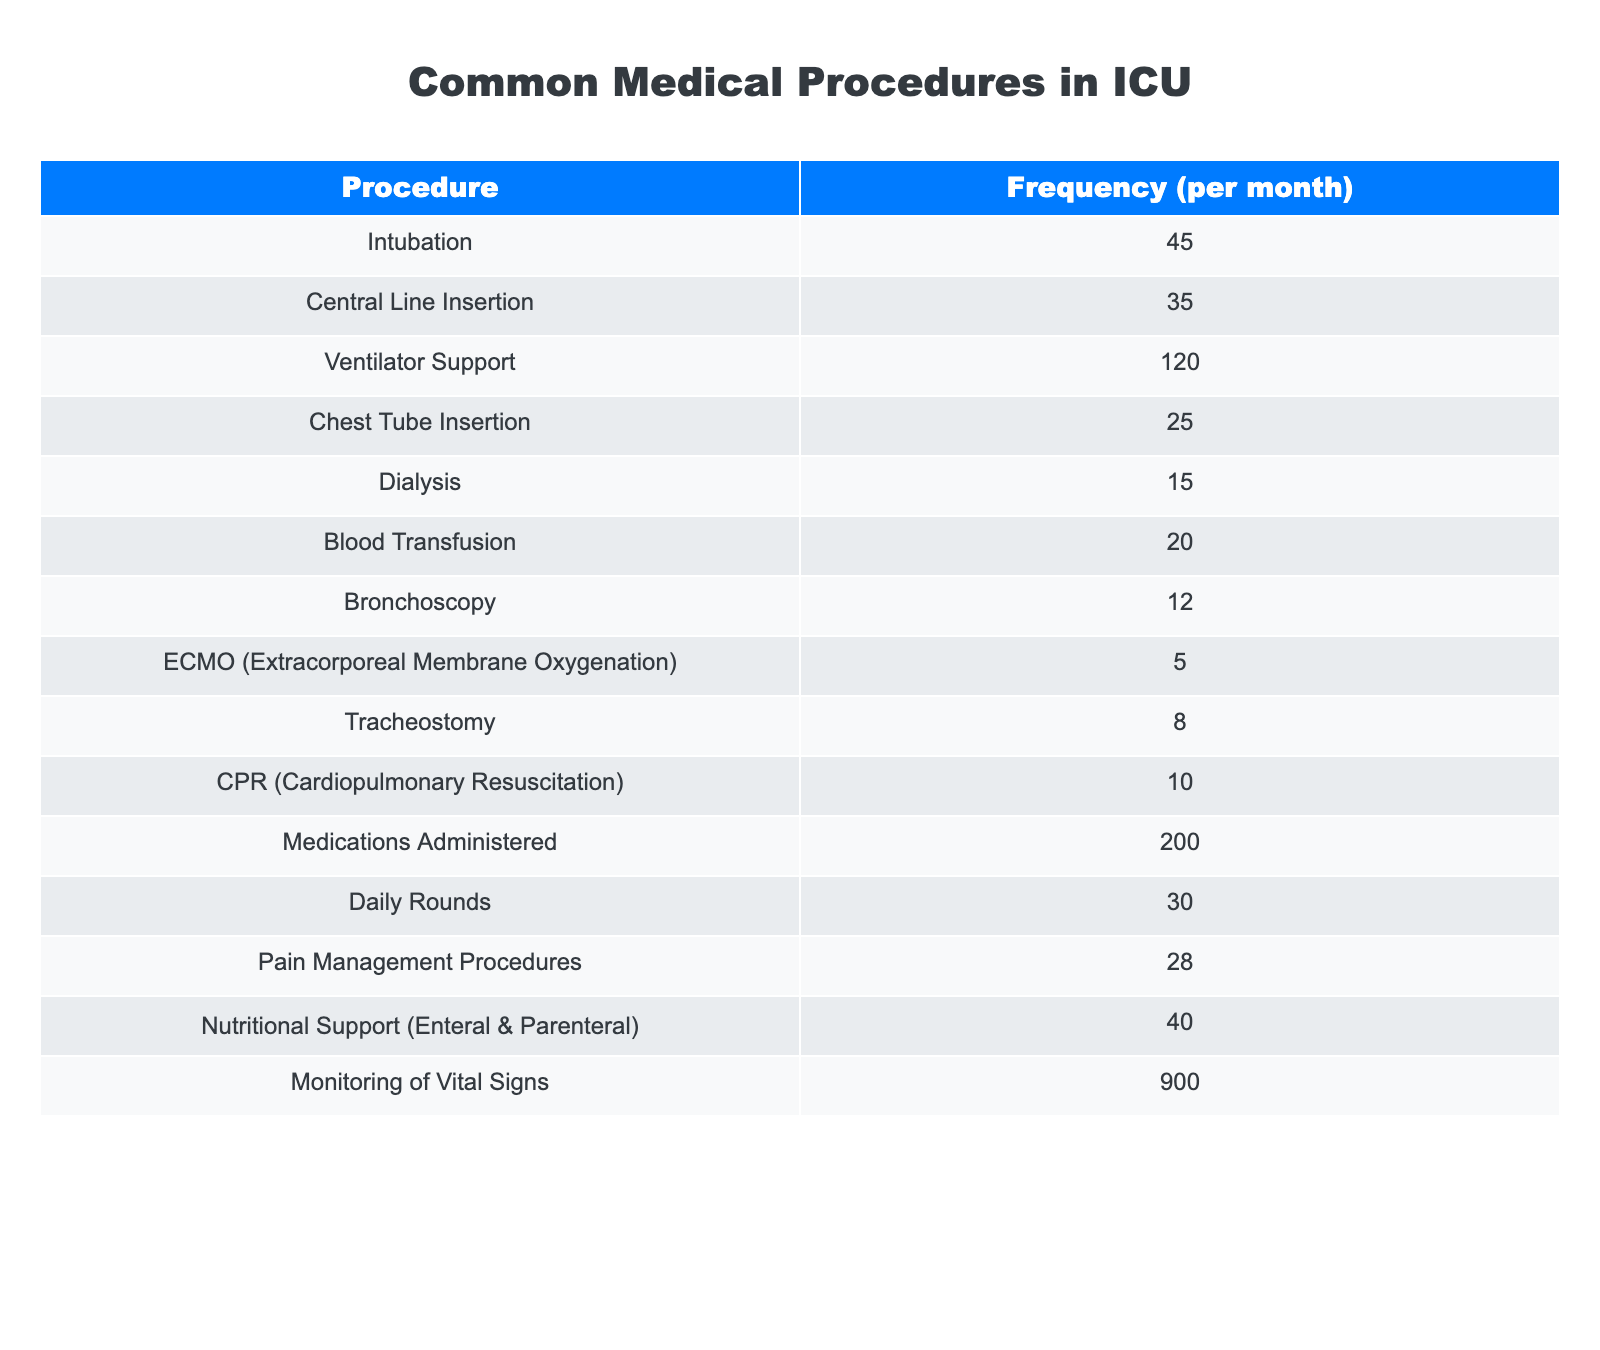What is the frequency of Ventilator Support in the ICU? The table clearly states that the frequency of Ventilator Support is listed as 120.
Answer: 120 How many more times is Intubation performed compared to Tracheostomy? The frequency of Intubation is 45 and Tracheostomy is 8. The difference is 45 - 8 = 37.
Answer: 37 Is the frequency of Dialysis greater than Blood Transfusion? The table lists Dialysis as 15 and Blood Transfusion as 20. Since 15 is less than 20, the answer is no.
Answer: No What is the total frequency of all procedures excluding ECMO? First, we need to sum all frequencies: (45 + 35 + 120 + 25 + 15 + 20 + 12 + 8 + 10 + 200 + 30 + 28 + 40 + 900) = 1418. We then subtract the frequency of ECMO, which is 5: 1418 - 5 = 1413.
Answer: 1413 How many procedures have a frequency of less than 20? From the table, the procedures with frequency less than 20 are Dialysis (15), Bronchoscopy (12), and ECMO (5). This totals to 3 procedures.
Answer: 3 What percentage of total medical procedures does Blood Transfusion represent? First, we calculate the total frequency of all procedures: 1418. Blood Transfusion's frequency is 20. To find the percentage: (20 / 1418) * 100 = 1.41%.
Answer: 1.41% How many more times are Medications Administered performed compared to Central Line Insertion? The Medications Administered frequency is 200 and Central Line Insertion is 35. The difference is 200 - 35 = 165.
Answer: 165 Is the total frequency of Monitoring Vital Signs more than all other procedures combined? The frequency of Monitoring Vital Signs is 900. We sum the frequencies of all other procedures: (45 + 35 + 120 + 25 + 15 + 20 + 12 + 5 + 8 + 10 + 200 + 30 + 28 + 40) = 400. Since 900 is greater than 400, the answer is yes.
Answer: Yes 